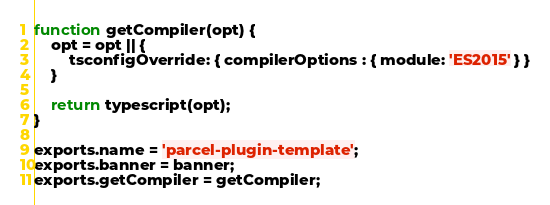<code> <loc_0><loc_0><loc_500><loc_500><_JavaScript_>
function getCompiler(opt) {
    opt = opt || {
        tsconfigOverride: { compilerOptions : { module: 'ES2015' } }
    }

    return typescript(opt);
}

exports.name = 'parcel-plugin-template';
exports.banner = banner;
exports.getCompiler = getCompiler;
</code> 